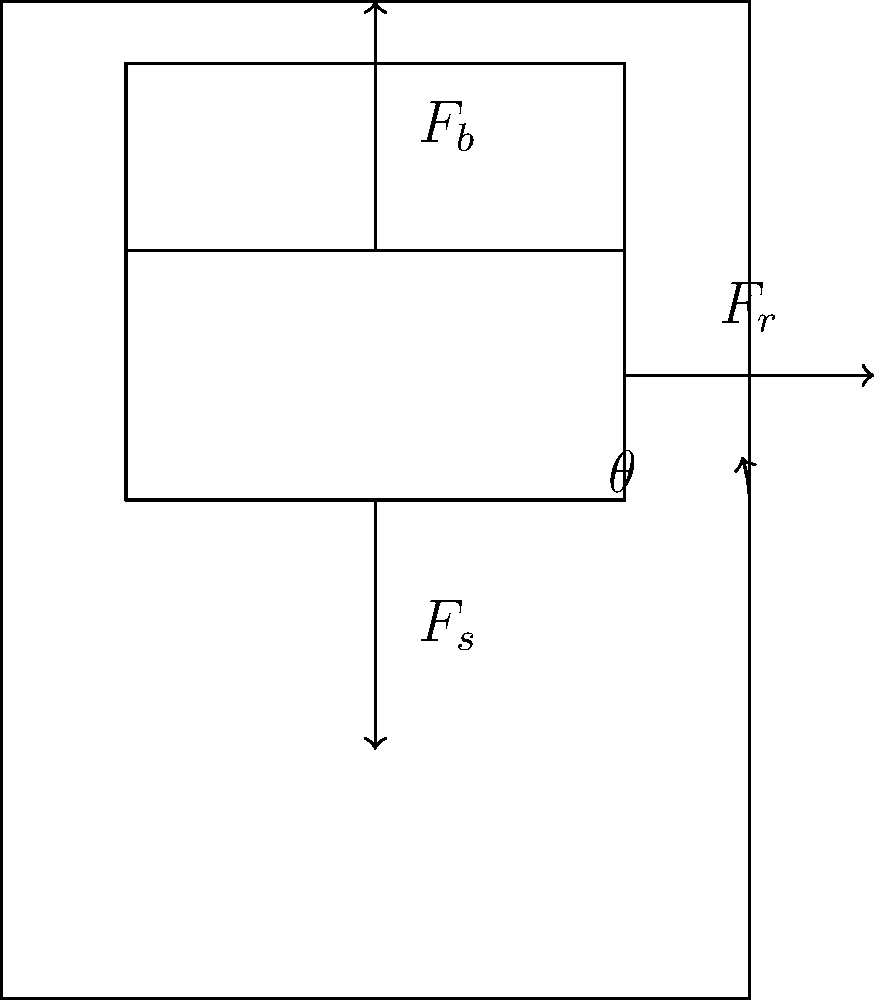In the ergonomic throne design shown above, what is the relationship between the backrest force ($F_b$), seat force ($F_s$), and reaction force ($F_r$) when the throne is in equilibrium? Assume the backrest is inclined at an angle $\theta$ from the vertical. To solve this problem, we need to consider the equilibrium conditions for the throne:

1. The sum of all forces in the x-direction must be zero: $\sum F_x = 0$
2. The sum of all forces in the y-direction must be zero: $\sum F_y = 0$

Let's break down the forces:

1. $F_s$ acts vertically upward on the seat.
2. $F_b$ acts perpendicular to the backrest, which is inclined at an angle $\theta$ from the vertical.
3. $F_r$ is the reaction force from the backrest support, acting horizontally.

We can resolve $F_b$ into its horizontal and vertical components:
- Horizontal component: $F_b \sin\theta$
- Vertical component: $F_b \cos\theta$

Now, let's apply the equilibrium conditions:

1. For x-direction equilibrium: $F_r = F_b \sin\theta$
2. For y-direction equilibrium: $F_s = F_b \cos\theta$

To find the relationship between all three forces, we can use the Pythagorean theorem:

$F_b^2 = (F_b \sin\theta)^2 + (F_b \cos\theta)^2$

Substituting the equilibrium conditions:

$F_b^2 = F_r^2 + F_s^2$

This equation represents the relationship between the three forces when the throne is in equilibrium.
Answer: $F_b^2 = F_r^2 + F_s^2$ 